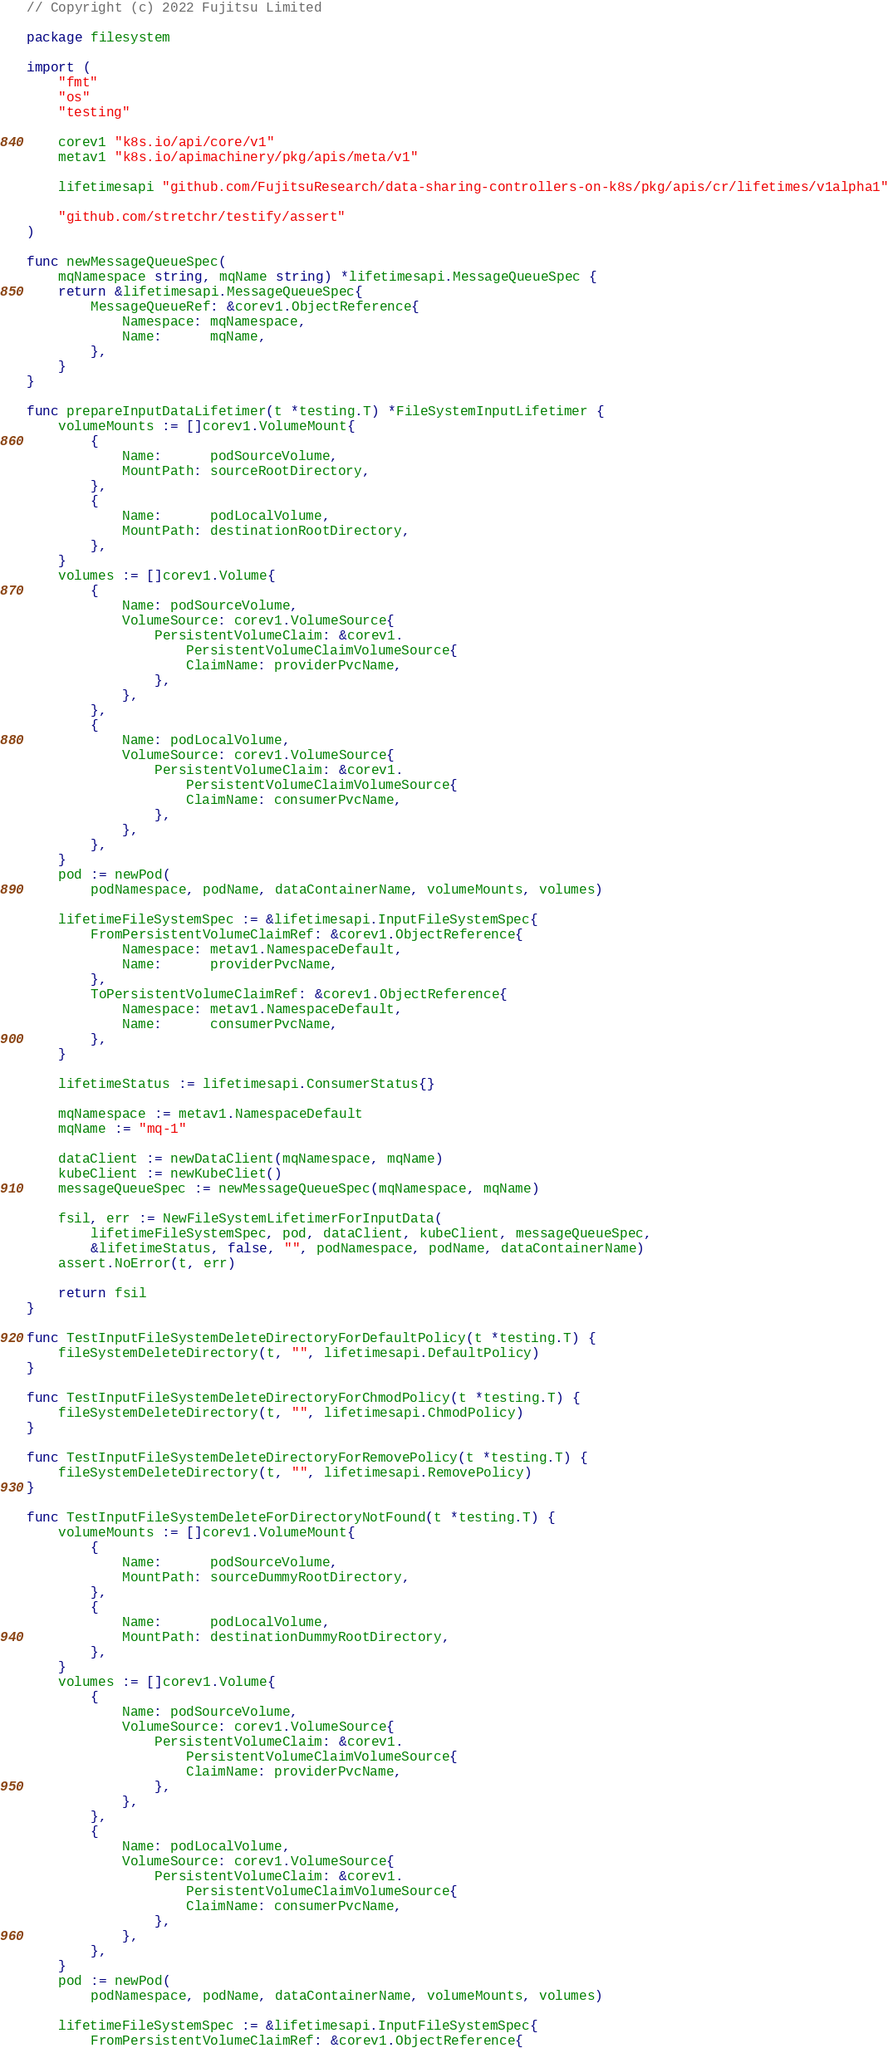Convert code to text. <code><loc_0><loc_0><loc_500><loc_500><_Go_>// Copyright (c) 2022 Fujitsu Limited

package filesystem

import (
	"fmt"
	"os"
	"testing"

	corev1 "k8s.io/api/core/v1"
	metav1 "k8s.io/apimachinery/pkg/apis/meta/v1"

	lifetimesapi "github.com/FujitsuResearch/data-sharing-controllers-on-k8s/pkg/apis/cr/lifetimes/v1alpha1"

	"github.com/stretchr/testify/assert"
)

func newMessageQueueSpec(
	mqNamespace string, mqName string) *lifetimesapi.MessageQueueSpec {
	return &lifetimesapi.MessageQueueSpec{
		MessageQueueRef: &corev1.ObjectReference{
			Namespace: mqNamespace,
			Name:      mqName,
		},
	}
}

func prepareInputDataLifetimer(t *testing.T) *FileSystemInputLifetimer {
	volumeMounts := []corev1.VolumeMount{
		{
			Name:      podSourceVolume,
			MountPath: sourceRootDirectory,
		},
		{
			Name:      podLocalVolume,
			MountPath: destinationRootDirectory,
		},
	}
	volumes := []corev1.Volume{
		{
			Name: podSourceVolume,
			VolumeSource: corev1.VolumeSource{
				PersistentVolumeClaim: &corev1.
					PersistentVolumeClaimVolumeSource{
					ClaimName: providerPvcName,
				},
			},
		},
		{
			Name: podLocalVolume,
			VolumeSource: corev1.VolumeSource{
				PersistentVolumeClaim: &corev1.
					PersistentVolumeClaimVolumeSource{
					ClaimName: consumerPvcName,
				},
			},
		},
	}
	pod := newPod(
		podNamespace, podName, dataContainerName, volumeMounts, volumes)

	lifetimeFileSystemSpec := &lifetimesapi.InputFileSystemSpec{
		FromPersistentVolumeClaimRef: &corev1.ObjectReference{
			Namespace: metav1.NamespaceDefault,
			Name:      providerPvcName,
		},
		ToPersistentVolumeClaimRef: &corev1.ObjectReference{
			Namespace: metav1.NamespaceDefault,
			Name:      consumerPvcName,
		},
	}

	lifetimeStatus := lifetimesapi.ConsumerStatus{}

	mqNamespace := metav1.NamespaceDefault
	mqName := "mq-1"

	dataClient := newDataClient(mqNamespace, mqName)
	kubeClient := newKubeCliet()
	messageQueueSpec := newMessageQueueSpec(mqNamespace, mqName)

	fsil, err := NewFileSystemLifetimerForInputData(
		lifetimeFileSystemSpec, pod, dataClient, kubeClient, messageQueueSpec,
		&lifetimeStatus, false, "", podNamespace, podName, dataContainerName)
	assert.NoError(t, err)

	return fsil
}

func TestInputFileSystemDeleteDirectoryForDefaultPolicy(t *testing.T) {
	fileSystemDeleteDirectory(t, "", lifetimesapi.DefaultPolicy)
}

func TestInputFileSystemDeleteDirectoryForChmodPolicy(t *testing.T) {
	fileSystemDeleteDirectory(t, "", lifetimesapi.ChmodPolicy)
}

func TestInputFileSystemDeleteDirectoryForRemovePolicy(t *testing.T) {
	fileSystemDeleteDirectory(t, "", lifetimesapi.RemovePolicy)
}

func TestInputFileSystemDeleteForDirectoryNotFound(t *testing.T) {
	volumeMounts := []corev1.VolumeMount{
		{
			Name:      podSourceVolume,
			MountPath: sourceDummyRootDirectory,
		},
		{
			Name:      podLocalVolume,
			MountPath: destinationDummyRootDirectory,
		},
	}
	volumes := []corev1.Volume{
		{
			Name: podSourceVolume,
			VolumeSource: corev1.VolumeSource{
				PersistentVolumeClaim: &corev1.
					PersistentVolumeClaimVolumeSource{
					ClaimName: providerPvcName,
				},
			},
		},
		{
			Name: podLocalVolume,
			VolumeSource: corev1.VolumeSource{
				PersistentVolumeClaim: &corev1.
					PersistentVolumeClaimVolumeSource{
					ClaimName: consumerPvcName,
				},
			},
		},
	}
	pod := newPod(
		podNamespace, podName, dataContainerName, volumeMounts, volumes)

	lifetimeFileSystemSpec := &lifetimesapi.InputFileSystemSpec{
		FromPersistentVolumeClaimRef: &corev1.ObjectReference{</code> 